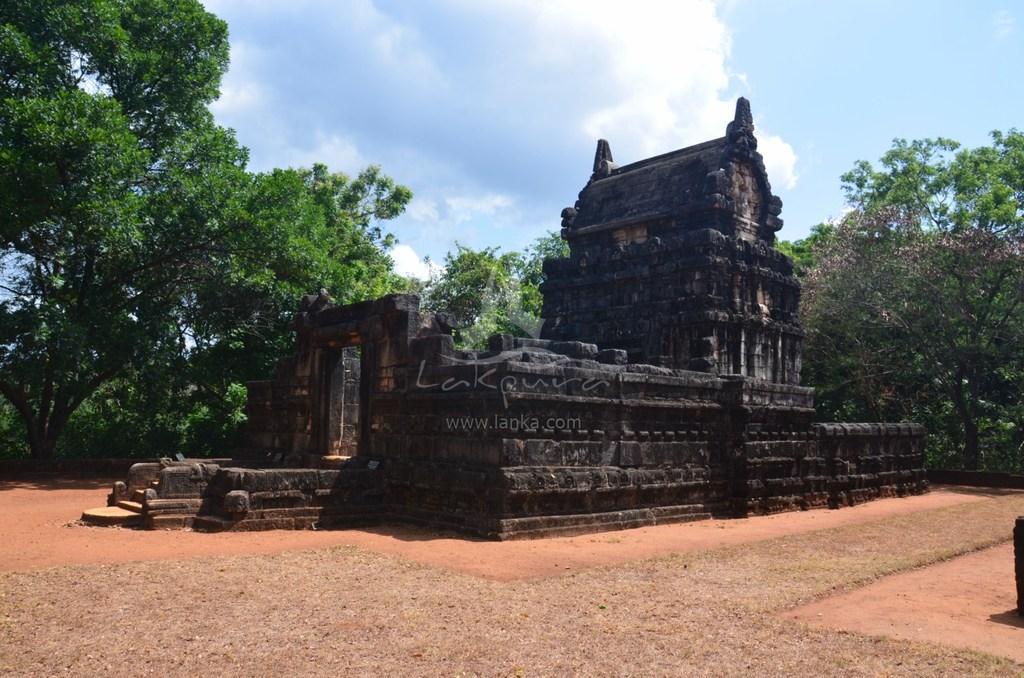Can you describe this image briefly? In this image we can see a monument which is in black color, behind the monument trees are there. The sky is in blue color with some clouds. 